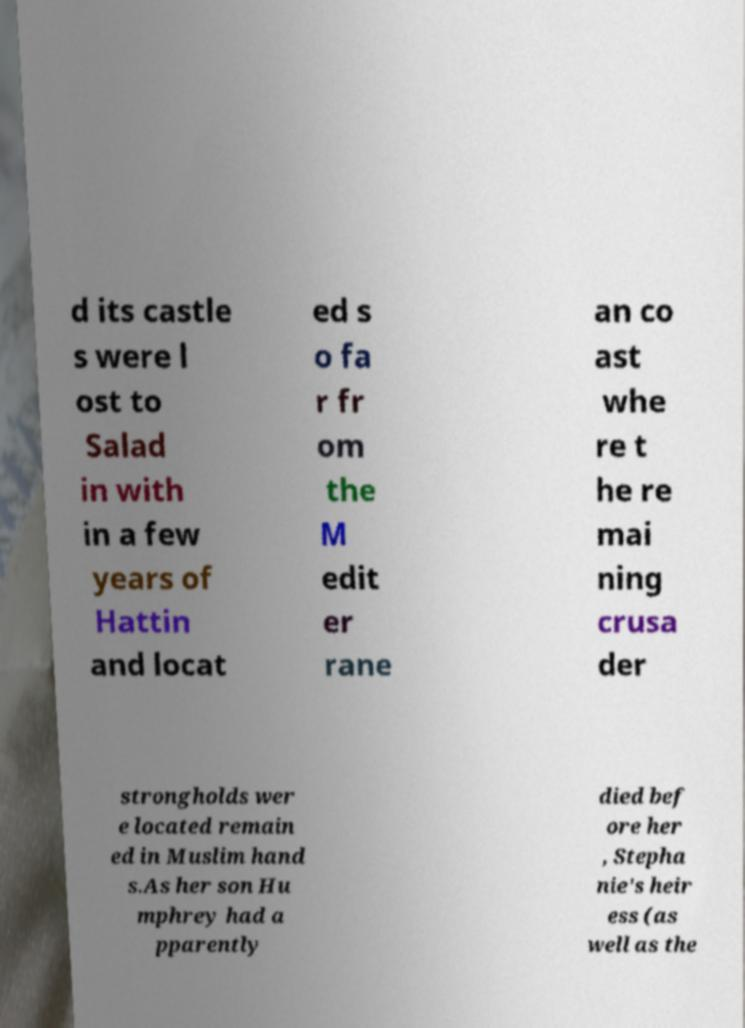Please read and relay the text visible in this image. What does it say? d its castle s were l ost to Salad in with in a few years of Hattin and locat ed s o fa r fr om the M edit er rane an co ast whe re t he re mai ning crusa der strongholds wer e located remain ed in Muslim hand s.As her son Hu mphrey had a pparently died bef ore her , Stepha nie's heir ess (as well as the 